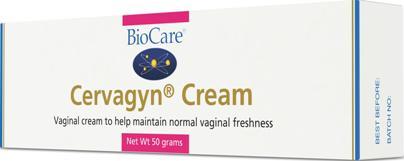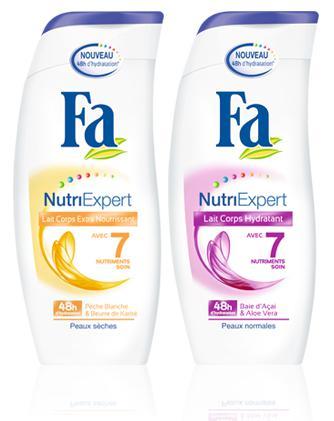The first image is the image on the left, the second image is the image on the right. For the images displayed, is the sentence "We see three packages of lotion." factually correct? Answer yes or no. Yes. 